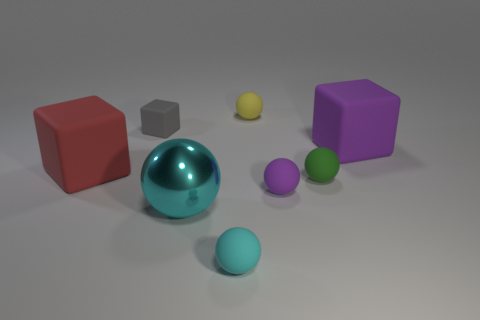Are there any other things that are the same material as the big ball?
Offer a terse response. No. How many cylinders are either cyan shiny things or big purple rubber objects?
Ensure brevity in your answer.  0. What color is the big rubber object that is to the right of the matte object in front of the big shiny sphere?
Ensure brevity in your answer.  Purple. Do the big ball and the small rubber sphere that is to the left of the yellow matte sphere have the same color?
Provide a succinct answer. Yes. What size is the cyan object that is made of the same material as the tiny gray thing?
Keep it short and to the point. Small. Are there any small balls right of the tiny yellow thing behind the big rubber object left of the green sphere?
Make the answer very short. Yes. How many objects are the same size as the cyan metallic ball?
Make the answer very short. 2. There is a rubber cube that is to the right of the yellow matte thing; is it the same size as the sphere that is in front of the large cyan ball?
Offer a very short reply. No. The rubber object that is in front of the green matte thing and right of the small cyan object has what shape?
Offer a very short reply. Sphere. Is there another matte ball that has the same color as the large sphere?
Provide a succinct answer. Yes. 